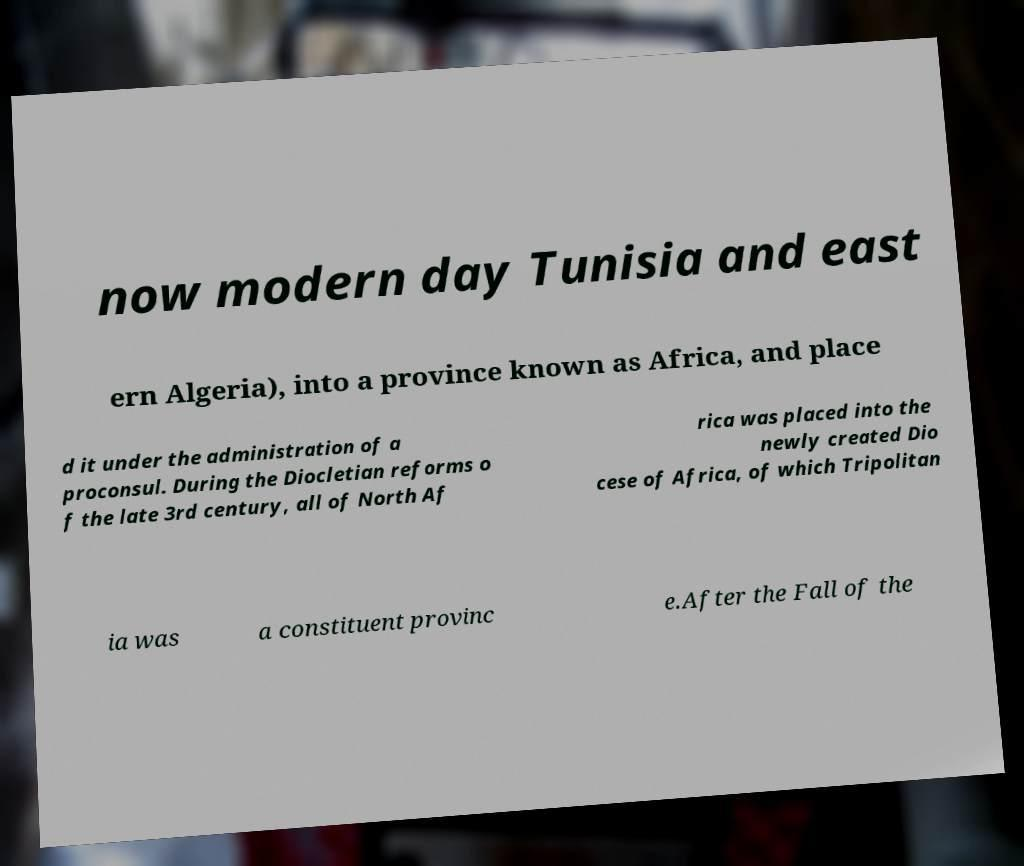Could you assist in decoding the text presented in this image and type it out clearly? now modern day Tunisia and east ern Algeria), into a province known as Africa, and place d it under the administration of a proconsul. During the Diocletian reforms o f the late 3rd century, all of North Af rica was placed into the newly created Dio cese of Africa, of which Tripolitan ia was a constituent provinc e.After the Fall of the 